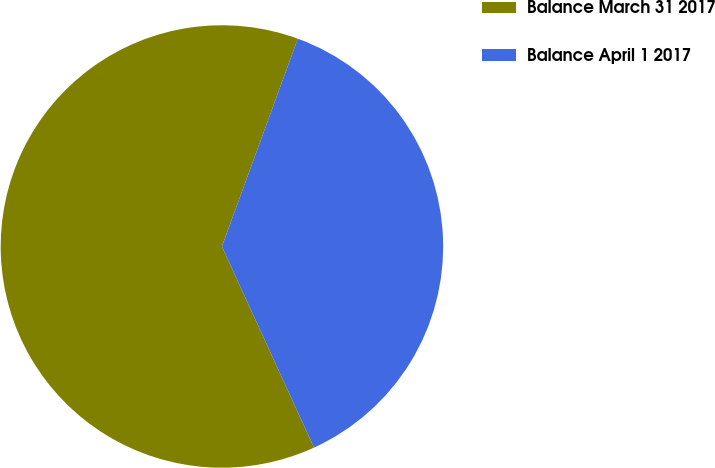Convert chart. <chart><loc_0><loc_0><loc_500><loc_500><pie_chart><fcel>Balance March 31 2017<fcel>Balance April 1 2017<nl><fcel>62.41%<fcel>37.59%<nl></chart> 